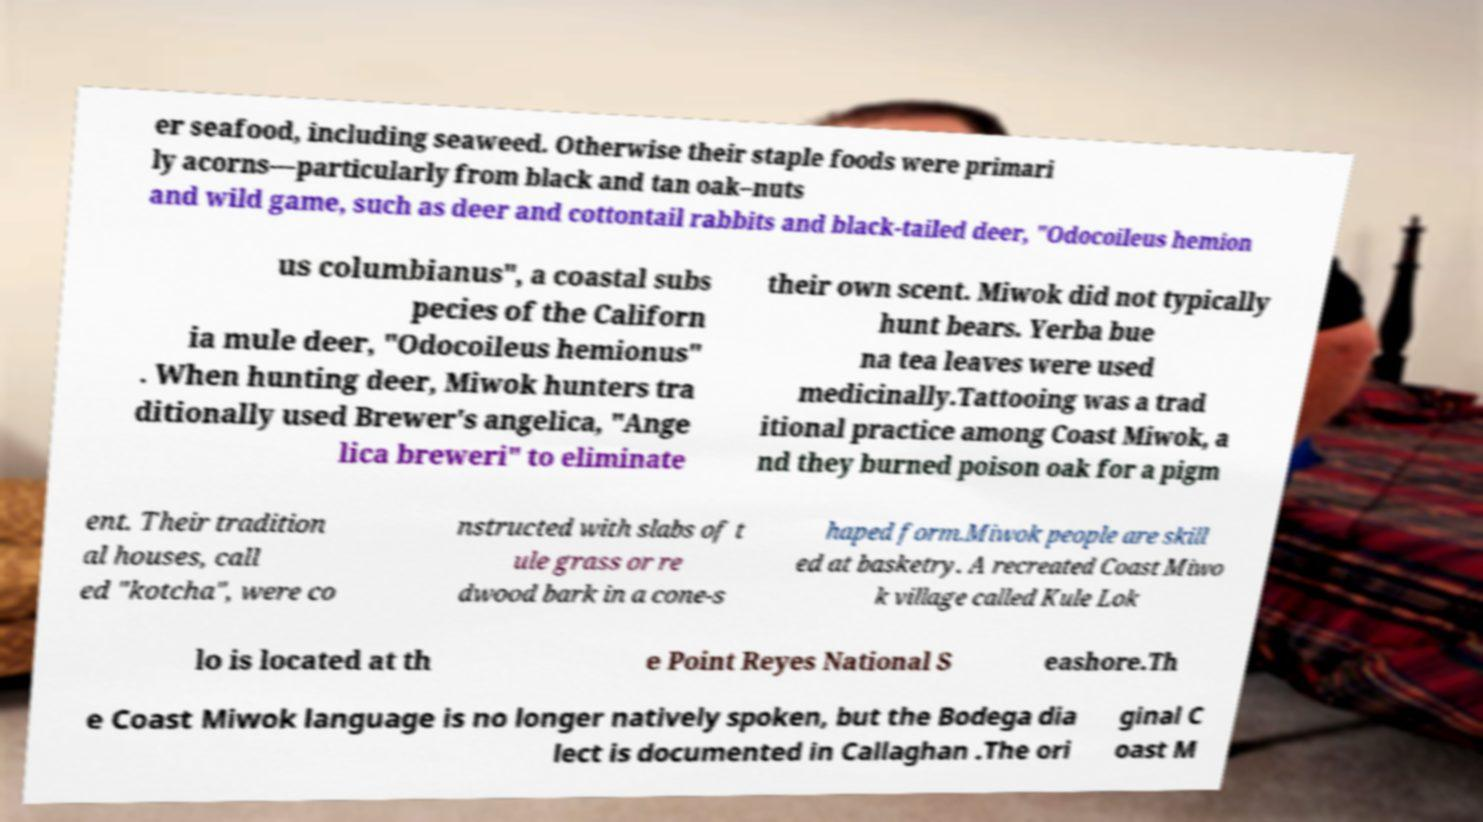Could you extract and type out the text from this image? er seafood, including seaweed. Otherwise their staple foods were primari ly acorns—particularly from black and tan oak–nuts and wild game, such as deer and cottontail rabbits and black-tailed deer, "Odocoileus hemion us columbianus", a coastal subs pecies of the Californ ia mule deer, "Odocoileus hemionus" . When hunting deer, Miwok hunters tra ditionally used Brewer's angelica, "Ange lica breweri" to eliminate their own scent. Miwok did not typically hunt bears. Yerba bue na tea leaves were used medicinally.Tattooing was a trad itional practice among Coast Miwok, a nd they burned poison oak for a pigm ent. Their tradition al houses, call ed "kotcha", were co nstructed with slabs of t ule grass or re dwood bark in a cone-s haped form.Miwok people are skill ed at basketry. A recreated Coast Miwo k village called Kule Lok lo is located at th e Point Reyes National S eashore.Th e Coast Miwok language is no longer natively spoken, but the Bodega dia lect is documented in Callaghan .The ori ginal C oast M 